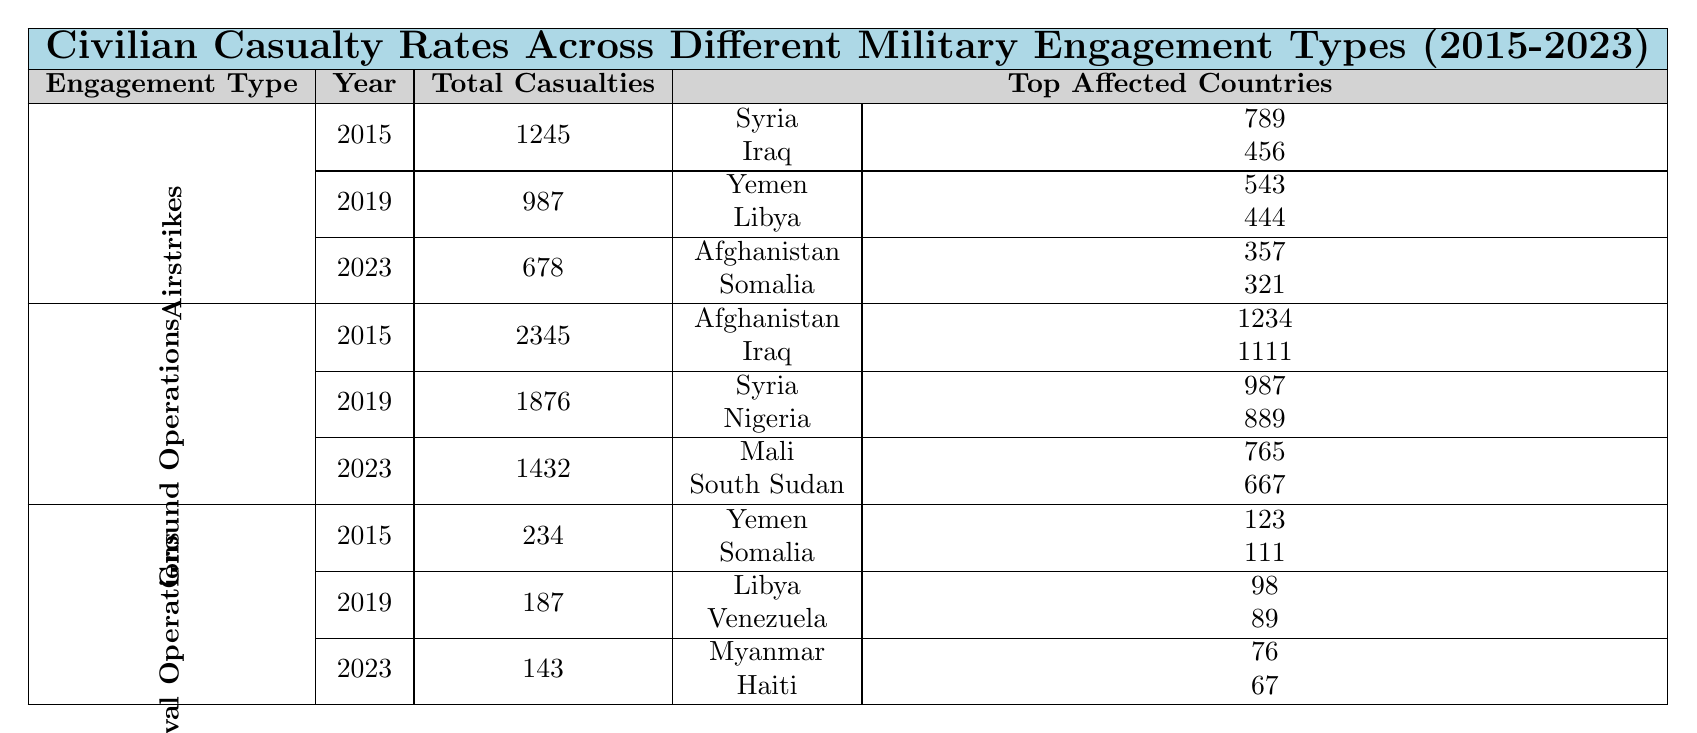What was the total number of civilian casualties in 2015 for Airstrikes? In 2015, the total civilian casualties for Airstrikes is listed as 1245.
Answer: 1245 Which country had the highest civilian casualties in Ground Operations in 2015? In 2015, Afghanistan had the highest casualties with 1234, compared to Iraq's 1111.
Answer: Afghanistan What were the civilian casualties in Naval Operations in 2023? The table shows that in 2023, the total civilian casualties for Naval Operations were 143.
Answer: 143 What is the total number of civilian casualties caused by Airstrikes from 2015 to 2023? The total civilian casualties for Airstrikes are 1245 (2015) + 987 (2019) + 678 (2023) = 2910.
Answer: 2910 Did the civilian casualties in Ground Operations increase or decrease from 2019 to 2023? In 2019, civilian casualties were 1876, and in 2023, they decreased to 1432. Thus, they decreased.
Answer: Decreased What are the civilian casualties in the top affected countries for Airstrikes in 2019? For Airstrikes in 2019, the top affected countries are Yemen (543) and Libya (444), summing up to 987 total casualties.
Answer: 987 Which type of military engagement had the lowest total civilian casualties in 2023? In 2023, Naval Operations had the lowest total casualties of 143 compared to Airstrikes (678) and Ground Operations (1432).
Answer: Naval Operations How many total civilian casualties were there across all engagement types in 2015? The total civilian casualties in 2015 are calculated as follows: Airstrikes (1245) + Ground Operations (2345) + Naval Operations (234) = 3824.
Answer: 3824 Is there a year where Airstrikes had more civilian casualties than Ground Operations? Yes, in 2015, Airstrikes had 1245 casualties, while Ground Operations had 2345. Ground Operations had more casualties that year.
Answer: No What is the average number of civilian casualties in Airstrikes from 2015 to 2023? The average is calculated by summing the casualties: (1245 + 987 + 678) = 2910, then dividing by 3, yielding an average of 970.
Answer: 970 What was the trend in civilian casualties for Naval Operations over the years? The casualties decreased from 234 in 2015 to 187 in 2019 and further to 143 in 2023, indicating a downward trend.
Answer: Downward trend 